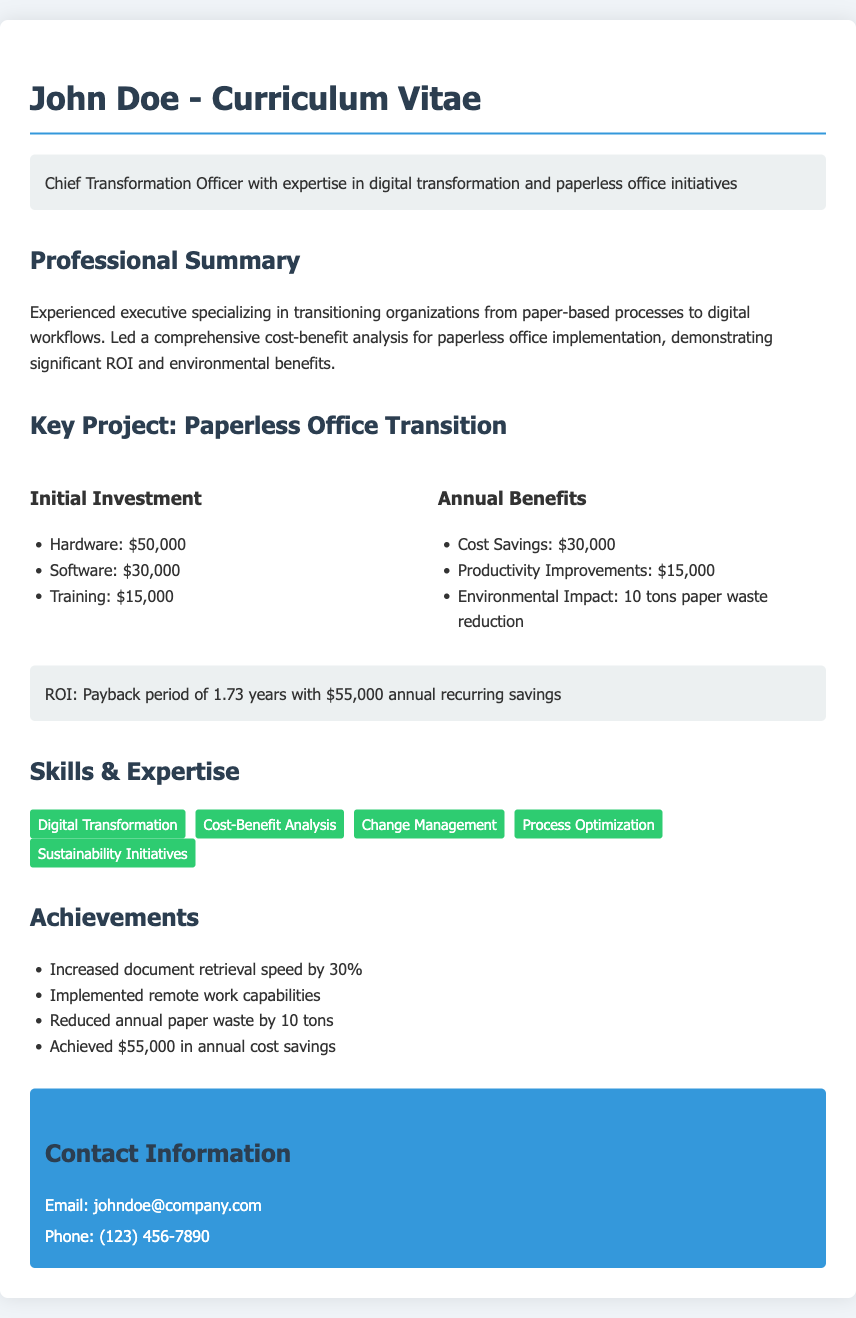what is the initial investment for hardware? The initial investment for hardware is listed in the document under the initial investment section.
Answer: $50,000 what is the annual cost savings from the transition? The annual cost savings is provided in the annual benefits section as part of the benefits of transitioning to a paperless office.
Answer: $30,000 how many tons of paper waste reduction is mentioned? The document states the environmental impact of the transition, specifically regarding the reduction in paper waste.
Answer: 10 tons what is the payback period for the investment? The payback period is mentioned in the ROI statement of the project section of the document.
Answer: 1.73 years list one skill highlighted in the skills section. The skills section includes multiple skills, and one can be selected as an example.
Answer: Digital Transformation how did the document define the role of John Doe? The document provides a brief professional summary which outlines John Doe's role and expertise.
Answer: Chief Transformation Officer what percentage increase in document retrieval speed is mentioned? The achievements section includes a specific percentage related to document retrieval speed improvement.
Answer: 30% what was the total initial investment? The total initial investment can be calculated by summing the individual components listed in the initial investment section.
Answer: $95,000 what is the experience focus of John Doe as described in the professional summary? The focus of John Doe's experience is described in terms of the type of initiatives led.
Answer: Digital workflows 